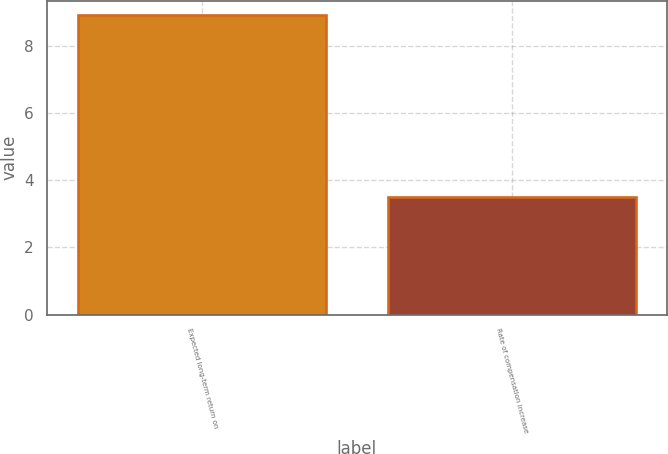<chart> <loc_0><loc_0><loc_500><loc_500><bar_chart><fcel>Expected long-term return on<fcel>Rate of compensation increase<nl><fcel>8.9<fcel>3.5<nl></chart> 